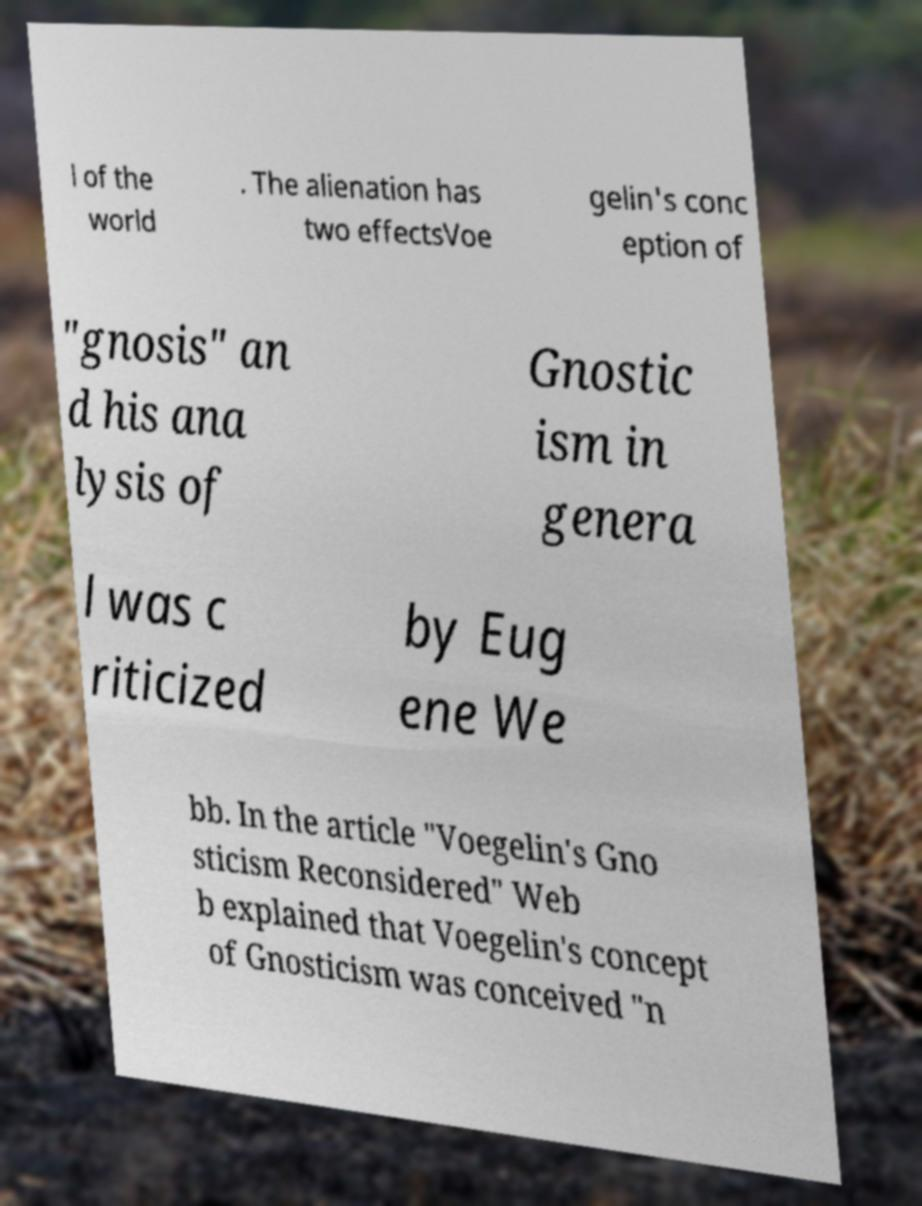Please identify and transcribe the text found in this image. l of the world . The alienation has two effectsVoe gelin's conc eption of "gnosis" an d his ana lysis of Gnostic ism in genera l was c riticized by Eug ene We bb. In the article "Voegelin's Gno sticism Reconsidered" Web b explained that Voegelin's concept of Gnosticism was conceived "n 